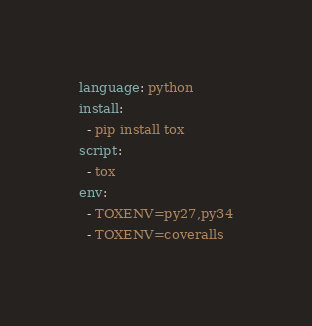<code> <loc_0><loc_0><loc_500><loc_500><_YAML_>language: python
install:
  - pip install tox 
script:
  - tox
env:
  - TOXENV=py27,py34
  - TOXENV=coveralls
</code> 